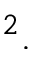<formula> <loc_0><loc_0><loc_500><loc_500>^ { 2 } .</formula> 